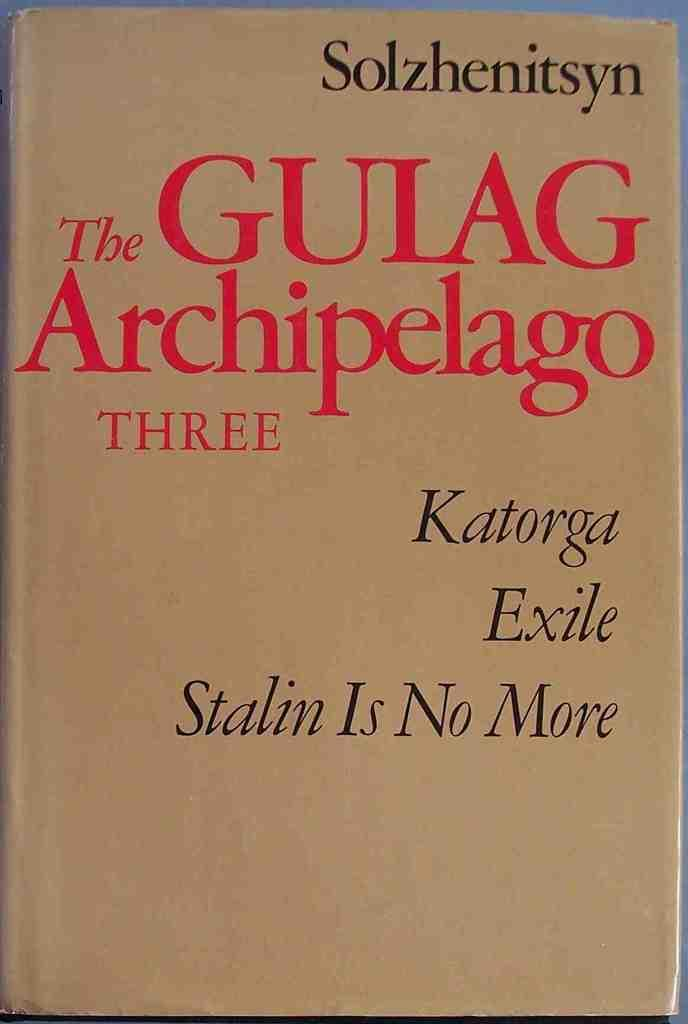What is the main subject of the image? The main subject of the image is a book cover. What can be seen on the book cover? There is writing on the book cover. What colors are used for the writing on the book cover? The writing on the book cover is in red and black colors. How many nerves are visible on the book cover in the image? There are no nerves visible on the book cover in the image. What type of hair is shown on the book cover in the image? There is no hair shown on the book cover in the image. 